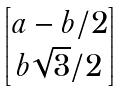<formula> <loc_0><loc_0><loc_500><loc_500>\begin{bmatrix} a - b / 2 \\ b \sqrt { 3 } / 2 \end{bmatrix}</formula> 